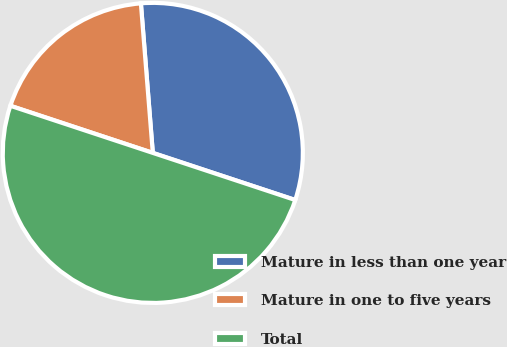<chart> <loc_0><loc_0><loc_500><loc_500><pie_chart><fcel>Mature in less than one year<fcel>Mature in one to five years<fcel>Total<nl><fcel>31.35%<fcel>18.65%<fcel>50.0%<nl></chart> 